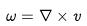Convert formula to latex. <formula><loc_0><loc_0><loc_500><loc_500>\omega = \nabla \times v</formula> 